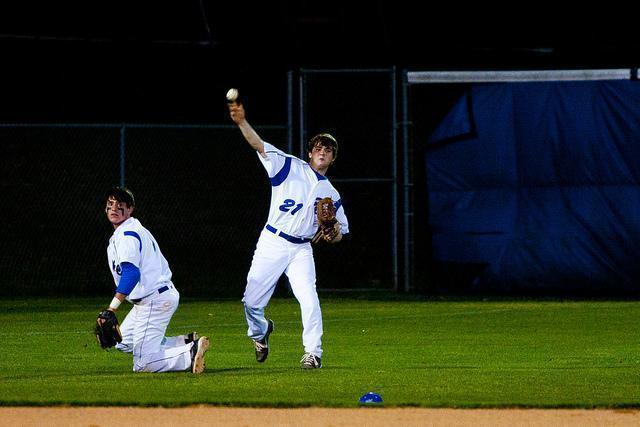What position is played by the kneeling player?
Answer the question by selecting the correct answer among the 4 following choices.
Options: Catcher, outfield, pitcher, short stop. Outfield. 